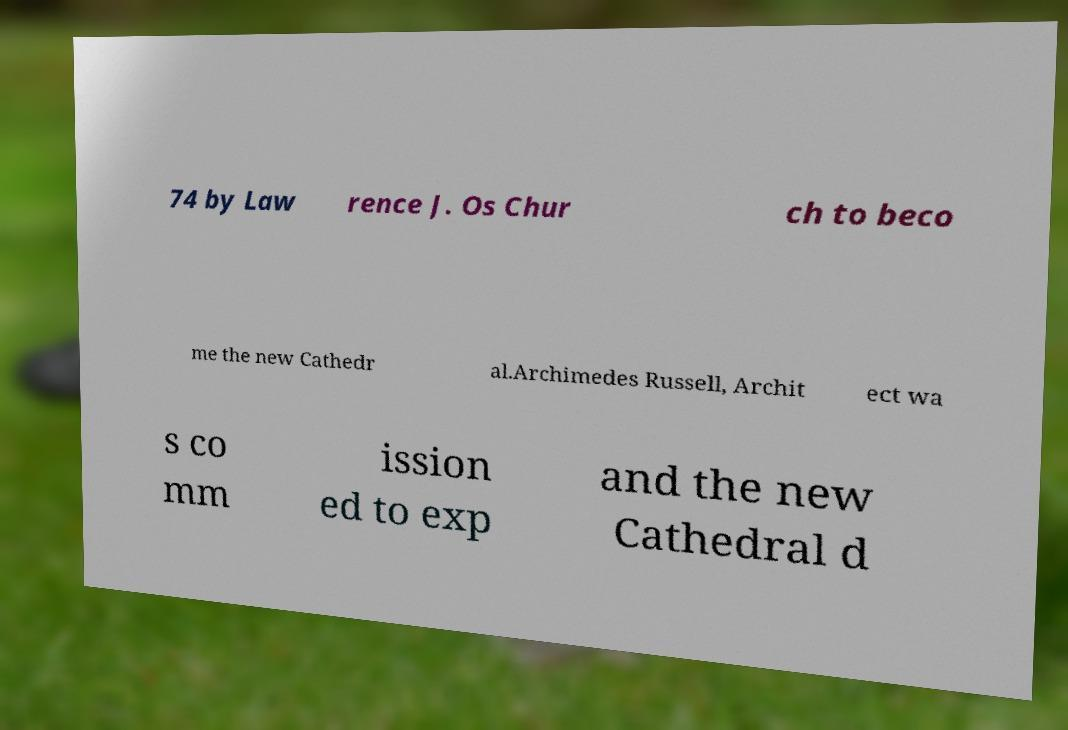Can you accurately transcribe the text from the provided image for me? 74 by Law rence J. Os Chur ch to beco me the new Cathedr al.Archimedes Russell, Archit ect wa s co mm ission ed to exp and the new Cathedral d 